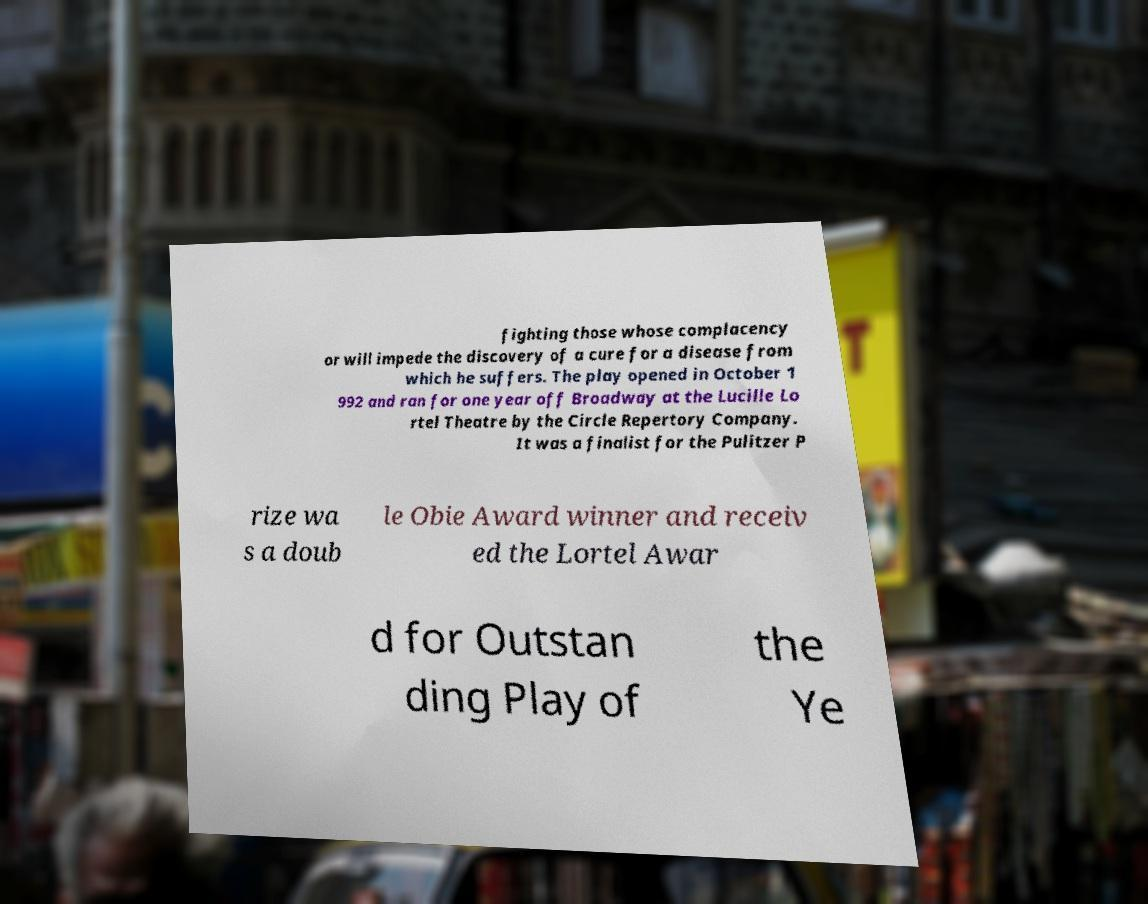Can you read and provide the text displayed in the image?This photo seems to have some interesting text. Can you extract and type it out for me? fighting those whose complacency or will impede the discovery of a cure for a disease from which he suffers. The play opened in October 1 992 and ran for one year off Broadway at the Lucille Lo rtel Theatre by the Circle Repertory Company. It was a finalist for the Pulitzer P rize wa s a doub le Obie Award winner and receiv ed the Lortel Awar d for Outstan ding Play of the Ye 